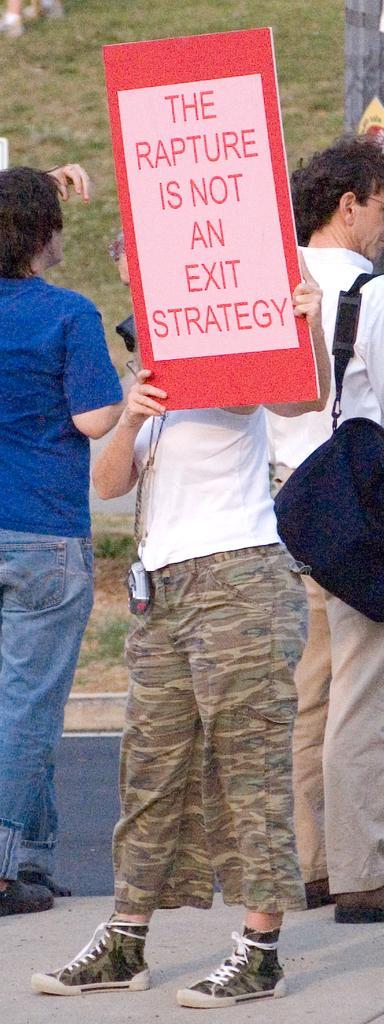Could you give a brief overview of what you see in this image? In this image, I can see three persons standing on the ground. Among them one person is holding a board. In the background, there is the grass. 